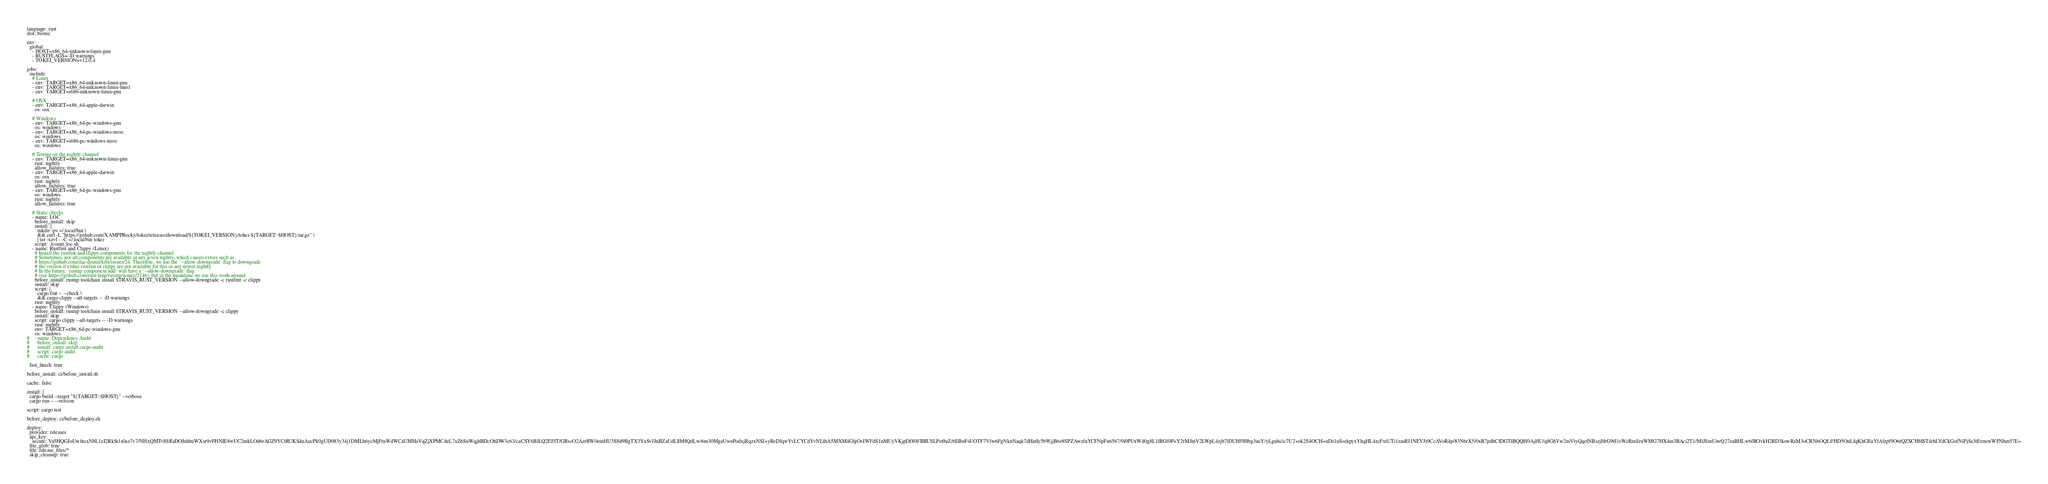Convert code to text. <code><loc_0><loc_0><loc_500><loc_500><_YAML_>language: rust
dist: bionic

env:
  global:
    - HOST=x86_64-unknown-linux-gnu
    - RUSTFLAGS='-D warnings'
    - TOKEI_VERSION=v12.0.4

jobs:
  include:
    # Linux
    - env: TARGET=x86_64-unknown-linux-gnu
    - env: TARGET=x86_64-unknown-linux-musl
    - env: TARGET=i686-unknown-linux-gnu

    # OSX
    - env: TARGET=x86_64-apple-darwin
      os: osx

    # Windows
    - env: TARGET=x86_64-pc-windows-gnu
      os: windows
    - env: TARGET=x86_64-pc-windows-msvc
      os: windows
    - env: TARGET=i686-pc-windows-msvc
      os: windows

    # Testing on the nightly channel
    - env: TARGET=x86_64-unknown-linux-gnu
      rust: nightly
      allow_failures: true
    - env: TARGET=x86_64-apple-darwin
      os: osx
      rust: nightly
      allow_failures: true
    - env: TARGET=x86_64-pc-windows-gnu
      os: windows
      rust: nightly
      allow_failures: true

    # Static checks
    - name: LOC
      before_install: skip
      install: |
        mkdir -pv ~/.local/bin \
        && curl -L "https://github.com/XAMPPRocky/tokei/releases/download/${TOKEI_VERSION}/tokei-${TARGET:-$HOST}.tar.gz" \
        | tar -xzvf - -C ~/.local/bin tokei
      script: ./count_loc.sh
    - name: Rustfmt and Clippy (Linux)
      # Install the rustfmt and clippy components for the nightly channel
      # Sometimes, not all components are available in any given nightly, which causes errors such as
      # https://github.com/ilai-deutel/kibi/issues/24. Therefore, we use the `--allow-downgrade` flag to downgrade
      # the version if either rustfmt or clippy are not available for this or any newer nightly.
      # In the future, `rustup component add` will have a `--allow-downgrade` flag
      # (see https://github.com/rust-lang/rustup/issues/2146), but in the meantime we use this work-around:
      before_install: rustup toolchain install $TRAVIS_RUST_VERSION --allow-downgrade -c rustfmt -c clippy
      install: skip
      script: |
        cargo fmt -- --check \
        && cargo clippy --all-targets -- -D warnings
      rust: nightly
    - name: Clippy (Windows)
      before_install: rustup toolchain install $TRAVIS_RUST_VERSION --allow-downgrade -c clippy
      install: skip
      script: cargo clippy --all-targets -- -D warnings
      rust: nightly
      env: TARGET=x86_64-pc-windows-gnu
      os: windows
#    - name: Dependency Audit
#      before_install: skip
#      install: cargo install cargo-audit
#      script: cargo audit
#      cache: cargo

  fast_finish: true

before_install: ci/before_install.sh

cache: false

install: |
  cargo build --target "${TARGET:-$HOST}" --verbose
  cargo run -- --version

script: cargo test

before_deploy: ci/before_deploy.sh

deploy:
  provider: releases
  api_key:
    secure: Va5HQGJoUwfnsxN8L1zI2RkSt1s0az7v7/NHxQMTv8SffaDOJuhbeWXsr9vFHNIE8wUC2mkLOd6rAGZ9YCtRUKS4nAucPk0gUD083y34j1DMLh6ycMjFtuWdWCaUMHaVqZjXPMCdeL7xZ6SuWqjhBDcOhDW3c63/caCSY6BlLQ2EFfT/GRscO2AzrRW0emHU3S8d9BgTX3YxSvJJnBZaUdLEbHQdLw/6m30MgaUwnPodxjRqzxNSJ+yReDJqwYvLCYCdYvNLlhA5MXM4GfgOsIWFdS1nMUyVKjpDf80f/BRUSLPst9uZ/6EBnFsUOTF7Vfw6FgNknNaqk7dHatIy5bWjjB6z8SPZAwzfnYCFNpFu6567/9i0PUxWd0g8L1lRGf0P+Y2rMJmV2LWpL4zjb7lDUHf9Hbg3ueY/yLguhi/ic7U2+ok2S4OCH+uDs1uSsekpyxYhqHL4zcFxtUTi1zasRI1NEVJr9CcAVoR4p/83N6rX5/0xR7pdhCfDGTlBQQH0AjHU/q8GhVw2mVlyQqefNBszjHrG9tI1oWcRmSruWMG7HX4m3BAci2T1/MlJSmUiwQ27eaBHLw6fROvkH2RD3kowRsM3oCRN6OQLf/HD5OnLfqKhGEaYlAfzpf9O6tQZSCHbIST4rhLYdCkGofNiPjSa3tErmoxWFNhm57E=
  file_glob: true
  file: release_files/*
  skip_cleanup: true</code> 